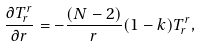<formula> <loc_0><loc_0><loc_500><loc_500>\frac { \partial T ^ { r } _ { r } } { \partial r } = - \frac { ( N - 2 ) } { r } ( 1 - k ) T ^ { r } _ { r } ,</formula> 